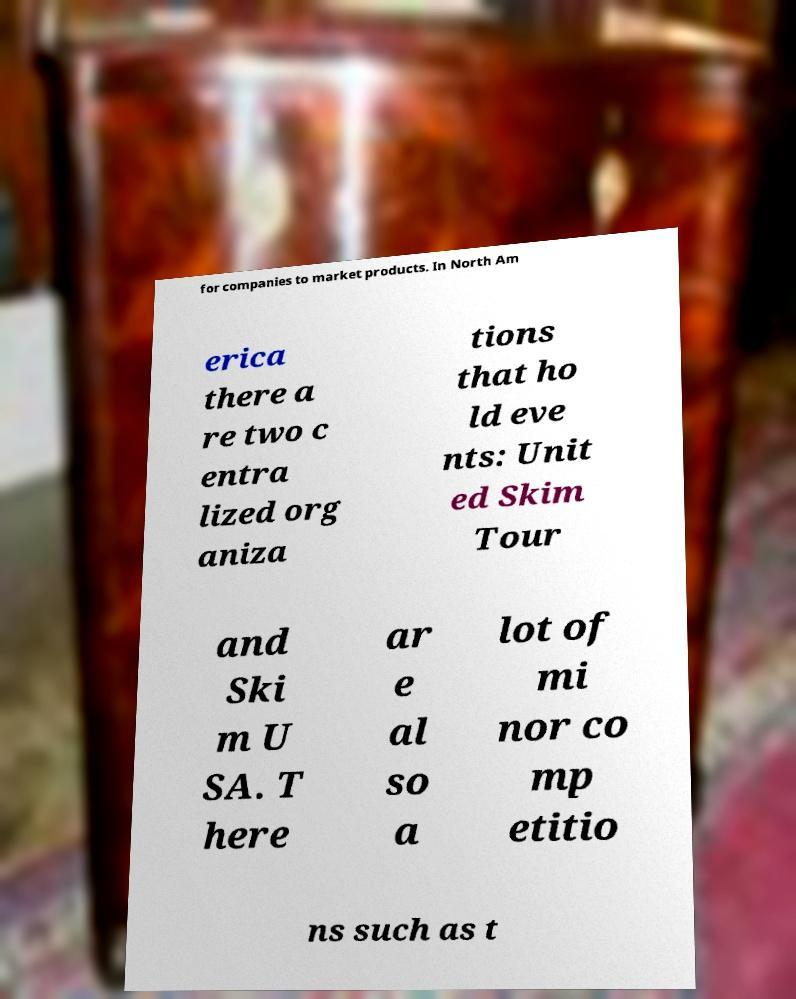Can you accurately transcribe the text from the provided image for me? for companies to market products. In North Am erica there a re two c entra lized org aniza tions that ho ld eve nts: Unit ed Skim Tour and Ski m U SA. T here ar e al so a lot of mi nor co mp etitio ns such as t 